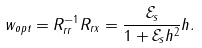<formula> <loc_0><loc_0><loc_500><loc_500>w _ { o p t } = R _ { r r } ^ { - 1 } R _ { r x } = \frac { \mathcal { E } _ { s } } { 1 + \mathcal { E } _ { s } \| h \| ^ { 2 } } h .</formula> 